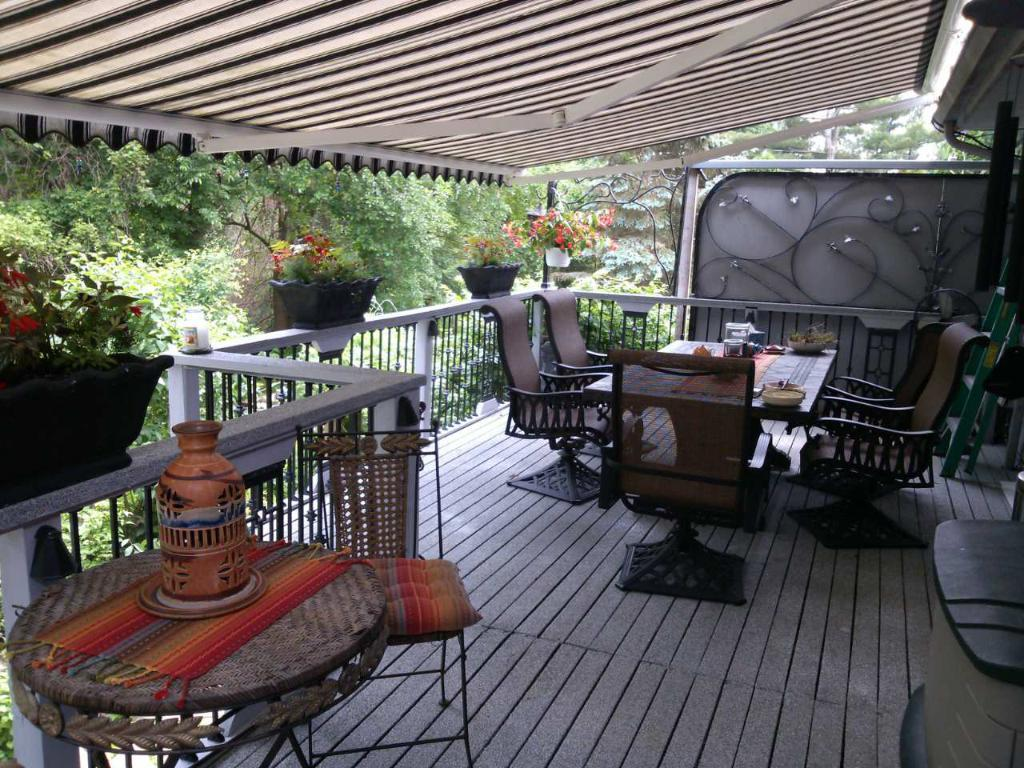What type of furniture is present in the image? There is a table and chairs in the image. What can be seen in the background of the image? There are trees in the background of the image. Where is the chair and flower vase located in the image? The chair and flower vase are on the left side of the image. What type of straw is used to cover the table in the image? There is no straw present in the image, nor is the table covered. 